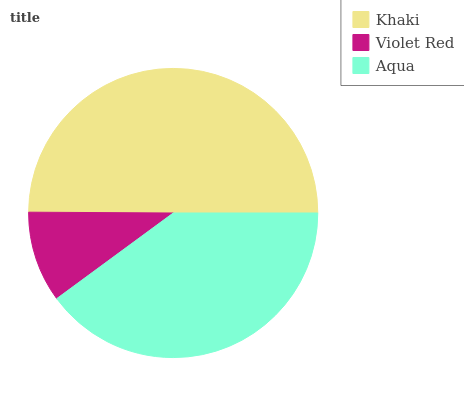Is Violet Red the minimum?
Answer yes or no. Yes. Is Khaki the maximum?
Answer yes or no. Yes. Is Aqua the minimum?
Answer yes or no. No. Is Aqua the maximum?
Answer yes or no. No. Is Aqua greater than Violet Red?
Answer yes or no. Yes. Is Violet Red less than Aqua?
Answer yes or no. Yes. Is Violet Red greater than Aqua?
Answer yes or no. No. Is Aqua less than Violet Red?
Answer yes or no. No. Is Aqua the high median?
Answer yes or no. Yes. Is Aqua the low median?
Answer yes or no. Yes. Is Violet Red the high median?
Answer yes or no. No. Is Khaki the low median?
Answer yes or no. No. 